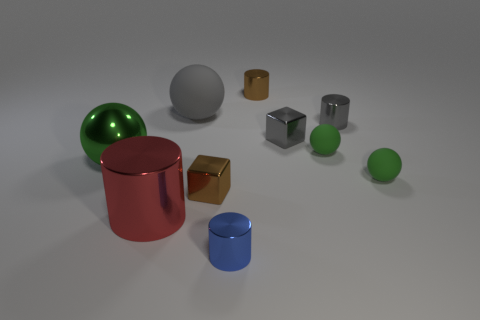Subtract all green balls. How many were subtracted if there are1green balls left? 2 Subtract all gray balls. How many balls are left? 3 Subtract all large cylinders. How many cylinders are left? 3 Subtract 0 yellow cubes. How many objects are left? 10 Subtract all cylinders. How many objects are left? 6 Subtract 4 cylinders. How many cylinders are left? 0 Subtract all brown spheres. Subtract all purple cylinders. How many spheres are left? 4 Subtract all brown cylinders. How many red balls are left? 0 Subtract all small metallic things. Subtract all big red things. How many objects are left? 4 Add 2 big gray matte objects. How many big gray matte objects are left? 3 